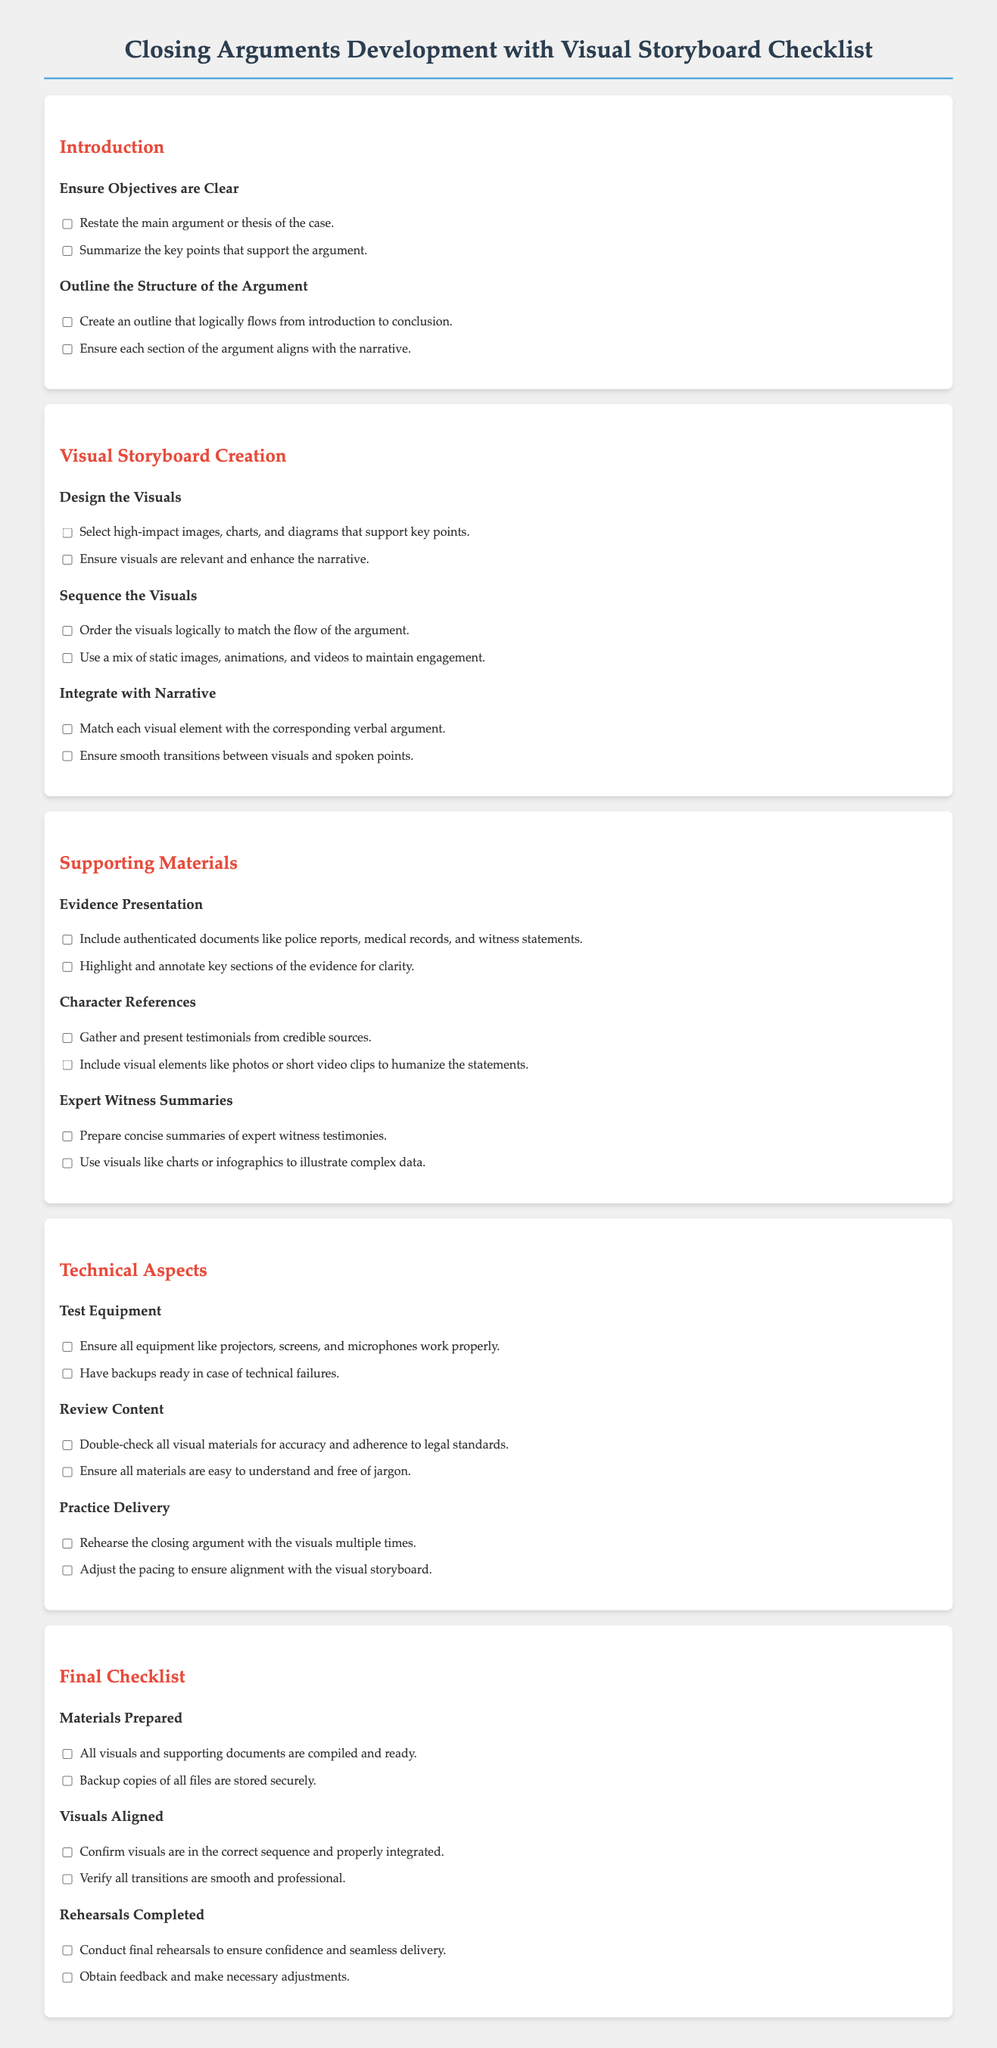what is one objective to ensure clarity in the introduction? The document states the importance of restating the main argument or thesis of the case to ensure a clear introduction.
Answer: restate the main argument or thesis of the case how many sections are there in the Visual Storyboard Creation portion? The document outlines three sections: Design the Visuals, Sequence the Visuals, and Integrate with Narrative.
Answer: three what type of evidence should be included in the Supporting Materials section? The checklist specifies including authenticated documents like police reports, medical records, and witness statements under Evidence Presentation.
Answer: authenticated documents what is the purpose of rehearsing the closing argument? The checklist indicates that rehearsing helps ensure confidence and seamless delivery in the final argument presentation.
Answer: ensure confidence and seamless delivery which materials should be prepared according to the Final Checklist? The document lists that all visuals and supporting documents should be compiled and ready in the Final Checklist section.
Answer: all visuals and supporting documents how many items are there to test equipment? The section on Technical Aspects includes two items related to testing equipment: ensuring all equipment works properly and having backups ready.
Answer: two what is required for visuals in the Visual Storyboard Creation? The checklist emphasizes selecting high-impact images, charts, and diagrams that support key points.
Answer: select high-impact images, charts, and diagrams what should be done with expert witness summaries? The document recommends preparing concise summaries of expert witness testimonies in the Supporting Materials section.
Answer: prepare concise summaries 